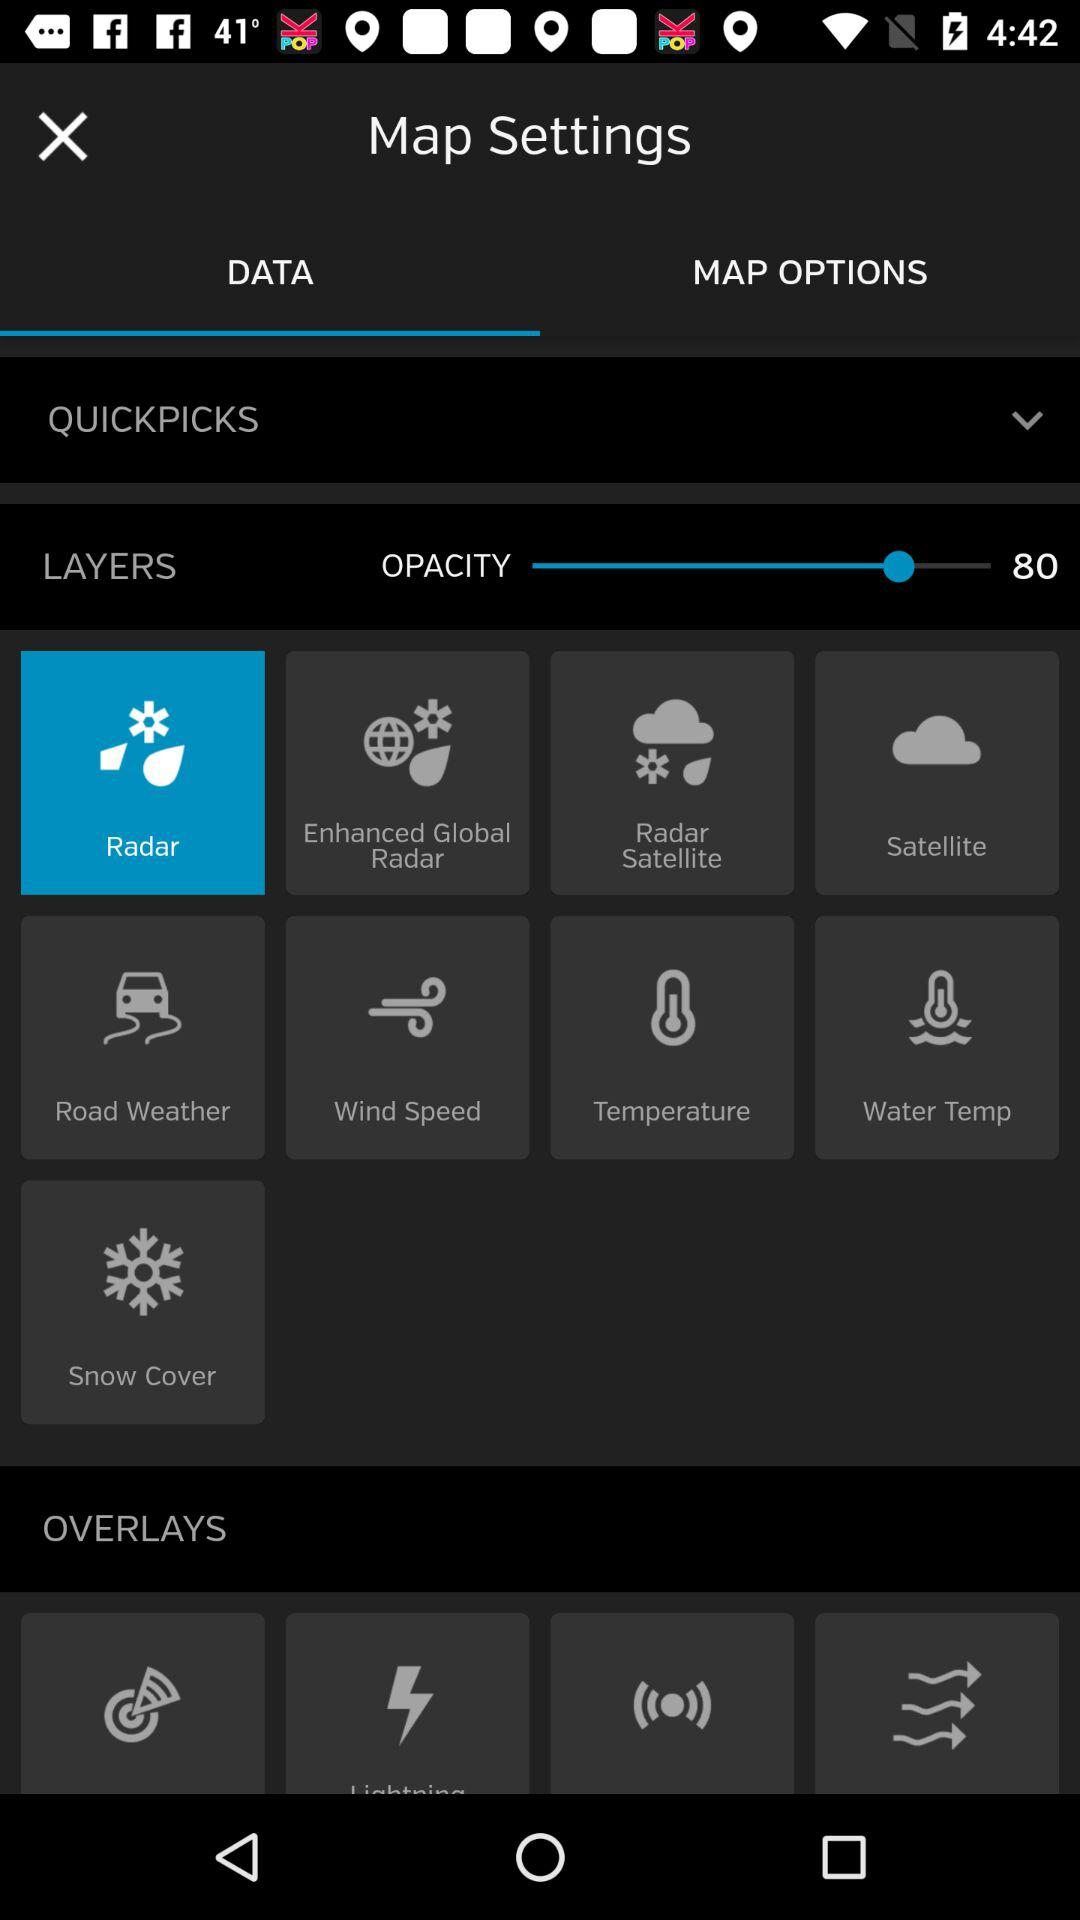What tab is currently selected under the "Map Settings"? The selected tab is "DATA". 